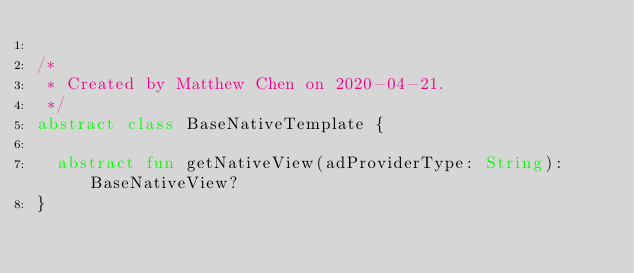<code> <loc_0><loc_0><loc_500><loc_500><_Kotlin_>
/*
 * Created by Matthew Chen on 2020-04-21.
 */
abstract class BaseNativeTemplate {

  abstract fun getNativeView(adProviderType: String): BaseNativeView?
}</code> 